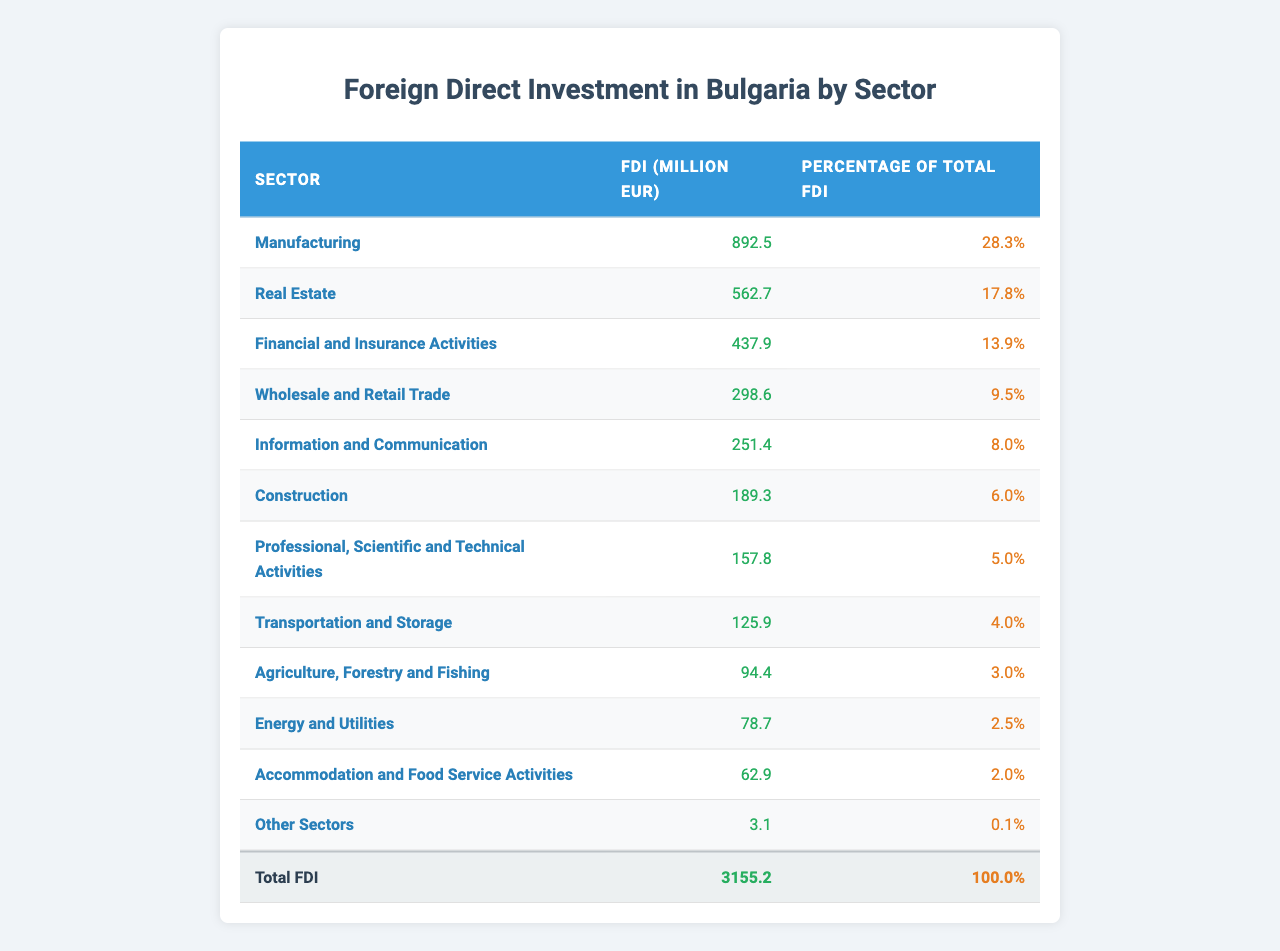What is the sector with the highest foreign direct investment in Bulgaria? By looking at the table, the sector 'Manufacturing' has the highest FDI at 892.5 million EUR.
Answer: Manufacturing How much foreign direct investment does the Real Estate sector attract? The table shows that the Real Estate sector attracts 562.7 million EUR in foreign direct investment.
Answer: 562.7 million EUR What percentage of total foreign direct investment does the Financial and Insurance Activities sector account for? The table indicates that the Financial and Insurance Activities sector accounts for 13.9% of the total FDI.
Answer: 13.9% What is the total foreign direct investment recorded for Bulgaria? The table provides the total FDI amount as 3155.2 million EUR.
Answer: 3155.2 million EUR What are the sectors that attracted less than 5% of the total foreign direct investment? Referring to the table, the sectors under 5% are Transportation and Storage (4.0%), Agriculture, Forestry and Fishing (3.0%), Energy and Utilities (2.5%), Accommodation and Food Service Activities (2.0%), and Other Sectors (0.1%).
Answer: Transportation and Storage, Agriculture, Forestry and Fishing, Energy and Utilities, Accommodation and Food Service Activities, Other Sectors If we combine the FDI from Construction and Professional, Scientific and Technical Activities, what will be the total? The FDI for Construction is 189.3 million EUR, and for Professional, Scientific and Technical Activities, it's 157.8 million EUR. Adding them gives: 189.3 + 157.8 = 347.1 million EUR.
Answer: 347.1 million EUR Does the Agriculture, Forestry and Fishing sector contribute to more than 5% of the total FDI? According to the table, the Agriculture, Forestry and Fishing sector contributes only 3.0% of the total FDI, which is less than 5%.
Answer: No What is the difference between the FDI in Manufacturing and Information and Communication sectors? The FDI in Manufacturing is 892.5 million EUR and in Information and Communication is 251.4 million EUR. The difference is: 892.5 - 251.4 = 641.1 million EUR.
Answer: 641.1 million EUR What sector makes up the smallest portion of total FDI? The table shows that 'Other Sectors' has the smallest portion of total FDI at only 0.1%.
Answer: Other Sectors What is the average percentage of FDI across the top three sectors? The top three sectors are Manufacturing (28.3%), Real Estate (17.8%), and Financial and Insurance Activities (13.9%). Their average percentage is calculated by: (28.3 + 17.8 + 13.9) / 3 = 20.0%.
Answer: 20.0% 